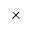<formula> <loc_0><loc_0><loc_500><loc_500>\times</formula> 